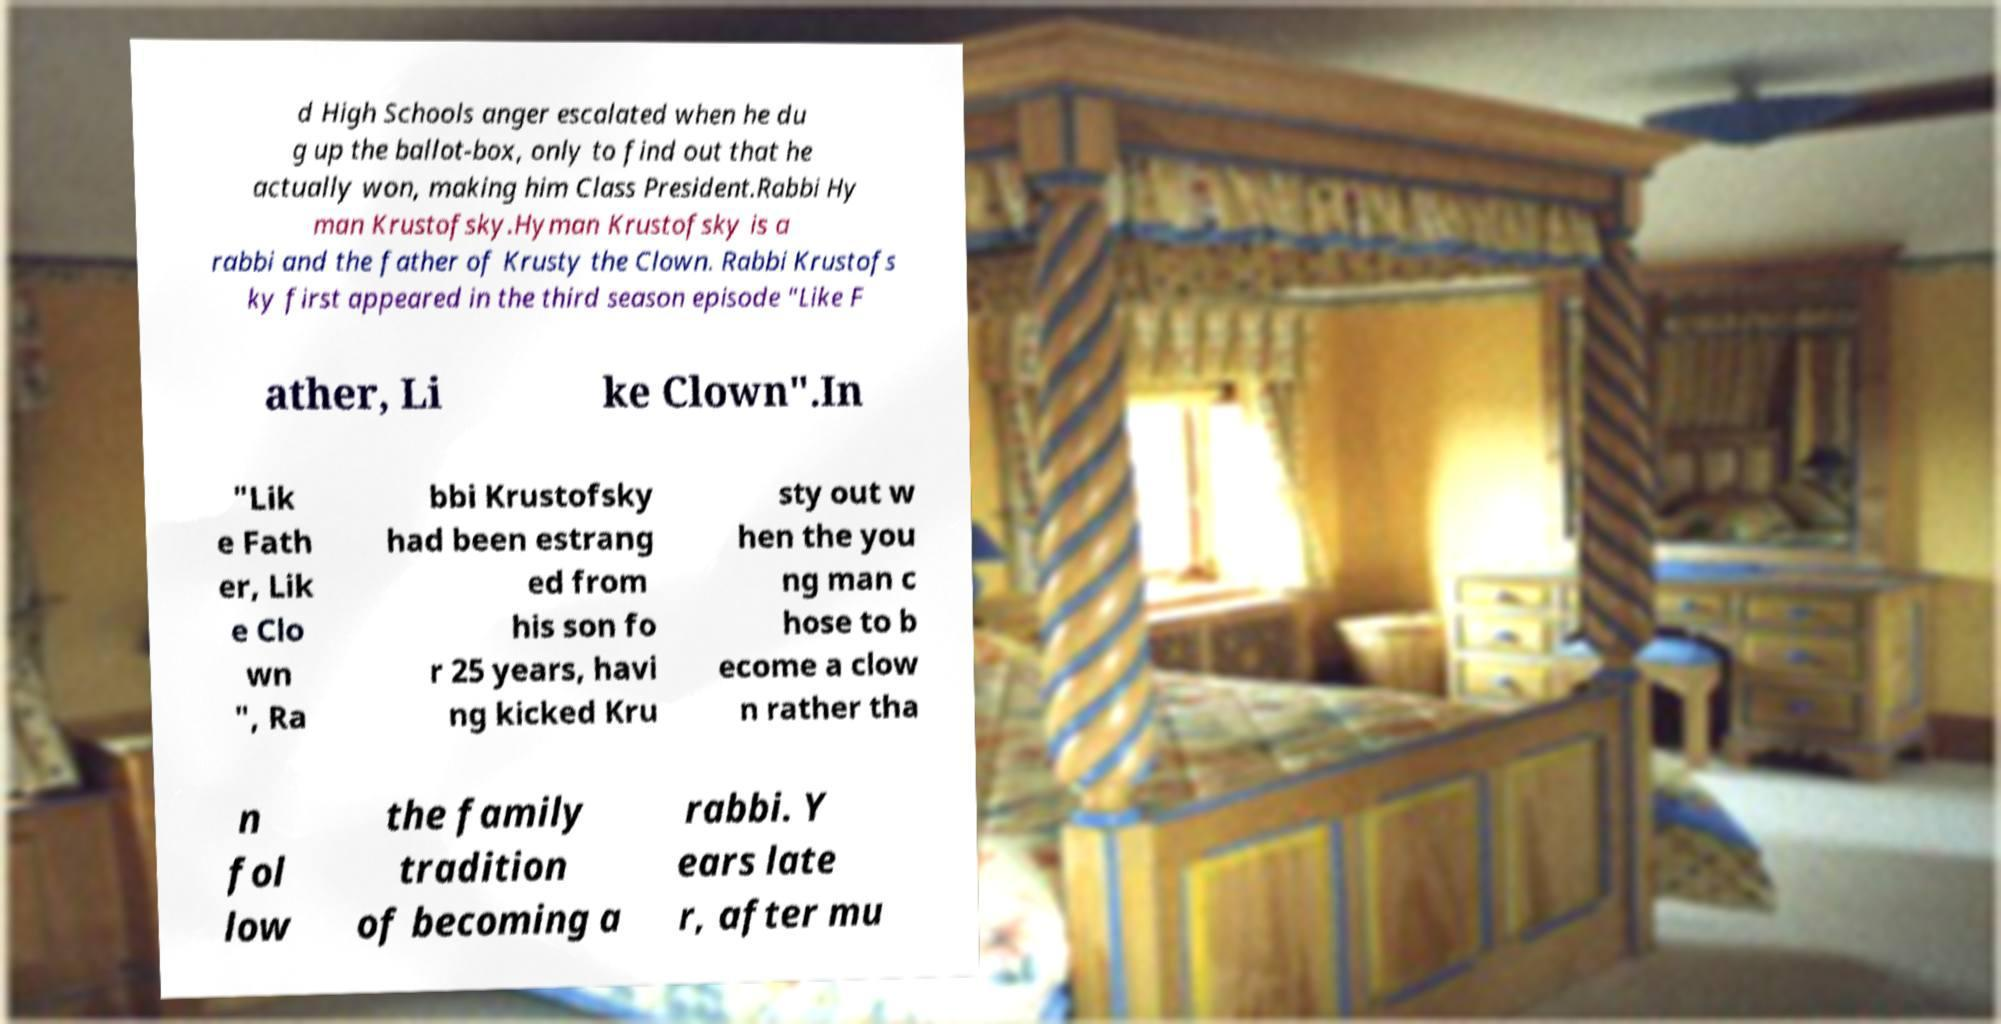Could you extract and type out the text from this image? d High Schools anger escalated when he du g up the ballot-box, only to find out that he actually won, making him Class President.Rabbi Hy man Krustofsky.Hyman Krustofsky is a rabbi and the father of Krusty the Clown. Rabbi Krustofs ky first appeared in the third season episode "Like F ather, Li ke Clown".In "Lik e Fath er, Lik e Clo wn ", Ra bbi Krustofsky had been estrang ed from his son fo r 25 years, havi ng kicked Kru sty out w hen the you ng man c hose to b ecome a clow n rather tha n fol low the family tradition of becoming a rabbi. Y ears late r, after mu 